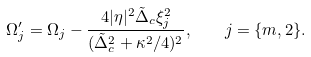Convert formula to latex. <formula><loc_0><loc_0><loc_500><loc_500>\Omega _ { j } ^ { \prime } = \Omega _ { j } - \frac { 4 | \eta | ^ { 2 } \tilde { \Delta } _ { c } \xi _ { j } ^ { 2 } } { ( \tilde { \Delta } _ { c } ^ { 2 } + \kappa ^ { 2 } / 4 ) ^ { 2 } } , \quad j = \{ m , 2 \} .</formula> 